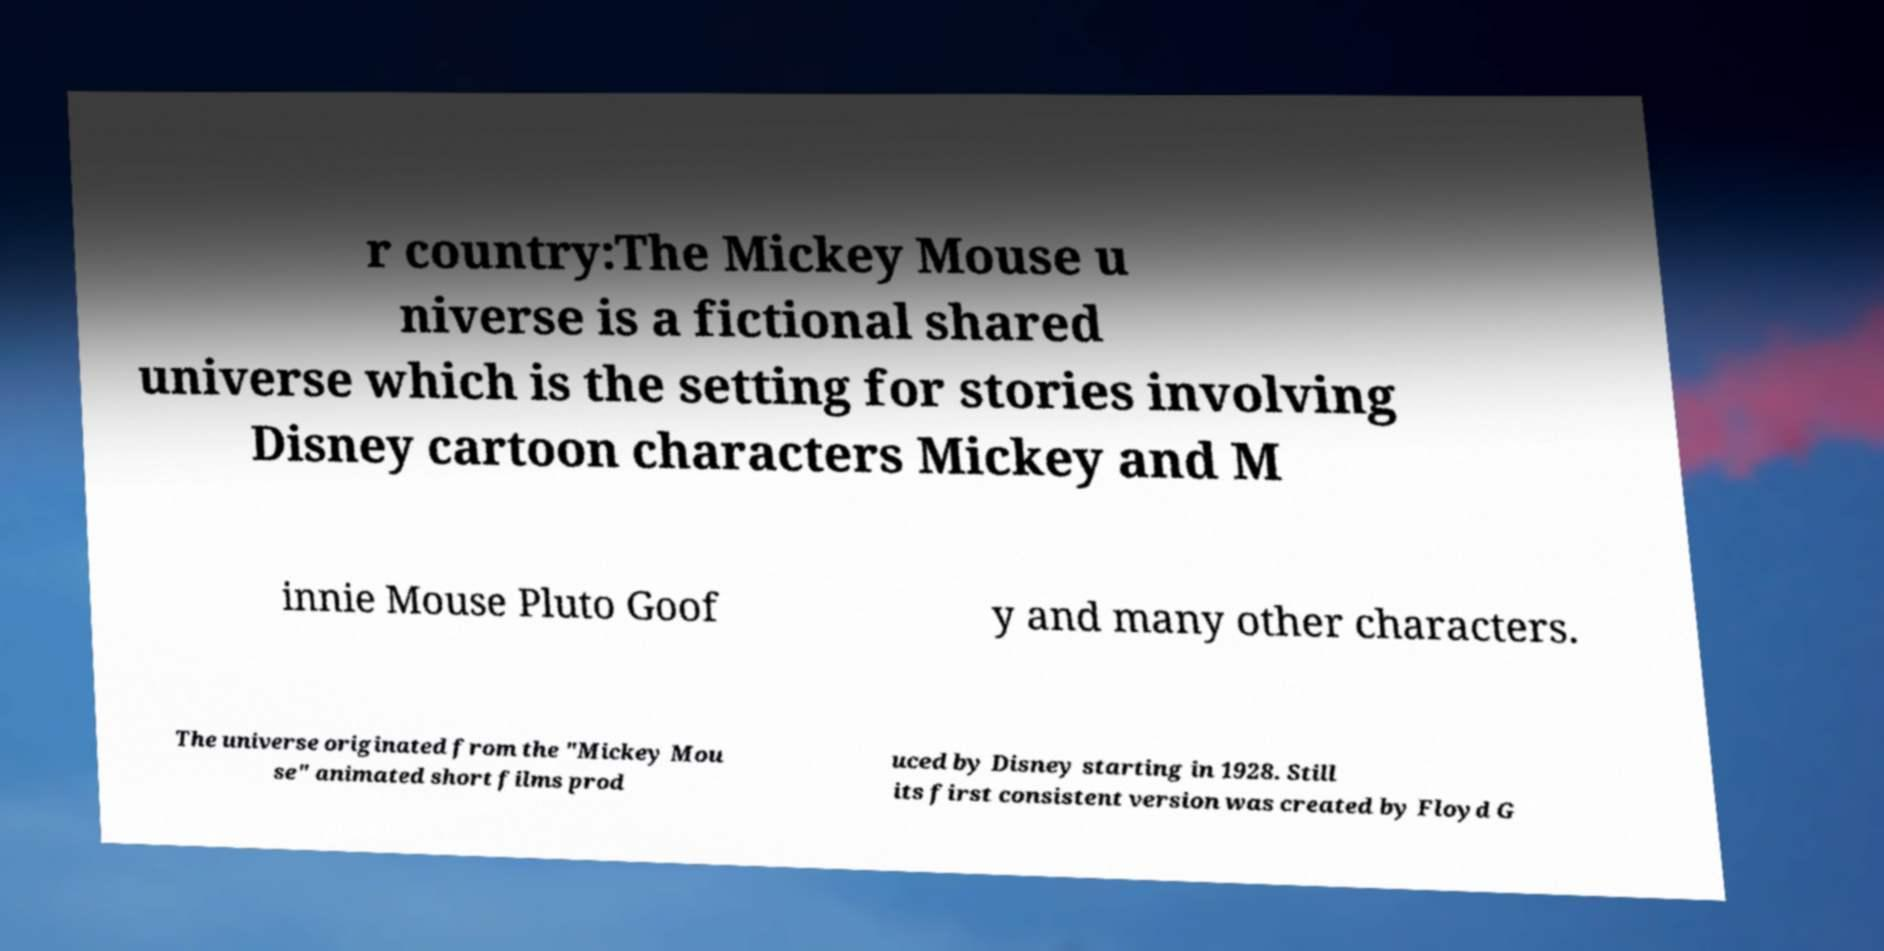Please read and relay the text visible in this image. What does it say? r country:The Mickey Mouse u niverse is a fictional shared universe which is the setting for stories involving Disney cartoon characters Mickey and M innie Mouse Pluto Goof y and many other characters. The universe originated from the "Mickey Mou se" animated short films prod uced by Disney starting in 1928. Still its first consistent version was created by Floyd G 